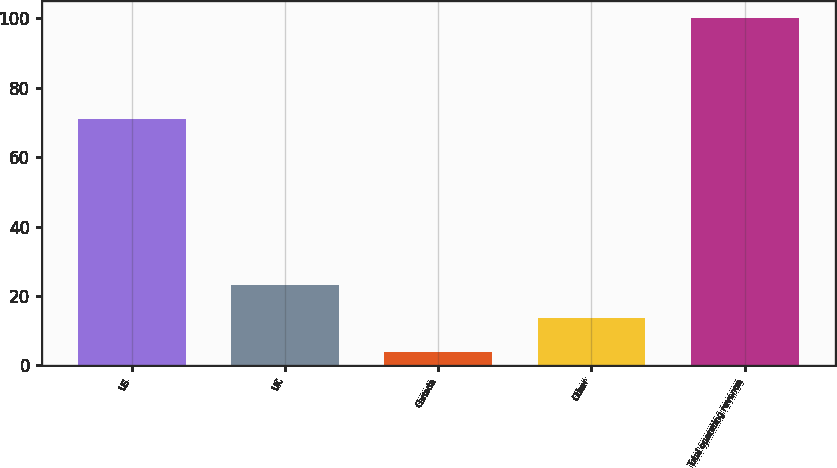Convert chart to OTSL. <chart><loc_0><loc_0><loc_500><loc_500><bar_chart><fcel>US<fcel>UK<fcel>Canada<fcel>Other<fcel>Total operating revenue<nl><fcel>71<fcel>23.2<fcel>4<fcel>13.6<fcel>100<nl></chart> 